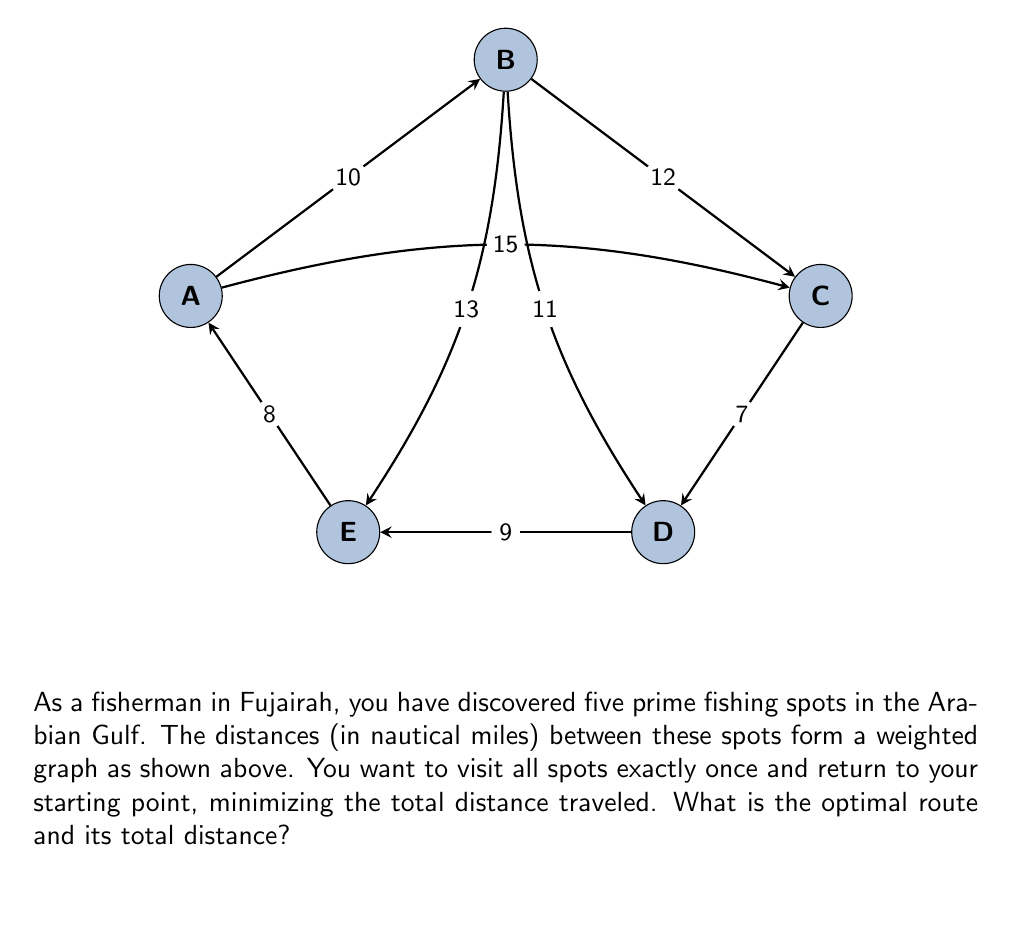Teach me how to tackle this problem. To solve this problem, we need to find the Hamiltonian cycle with the minimum total weight in the given graph. This is known as the Traveling Salesman Problem (TSP).

Step 1: Identify all possible Hamiltonian cycles.
There are $(5-1)! = 24$ possible cycles, as we can fix the starting point and permute the rest.

Step 2: Calculate the total distance for each cycle.
Let's calculate a few examples:
A-B-C-D-E-A: $10 + 12 + 7 + 9 + 8 = 46$
A-B-D-C-E-A: $10 + 11 + 7 + 15 + 8 = 51$
A-C-B-D-E-A: $15 + 12 + 11 + 9 + 8 = 55$

Step 3: Compare all cycles to find the minimum.
After calculating all 24 cycles, we find that A-B-C-D-E-A (and its reverse) have the minimum total distance of 46 nautical miles.

Step 4: Verify the optimal route.
The optimal route A-B-C-D-E-A visits all spots exactly once and returns to the starting point, satisfying the problem constraints.
Answer: Optimal route: A-B-C-D-E-A; Total distance: 46 nautical miles 